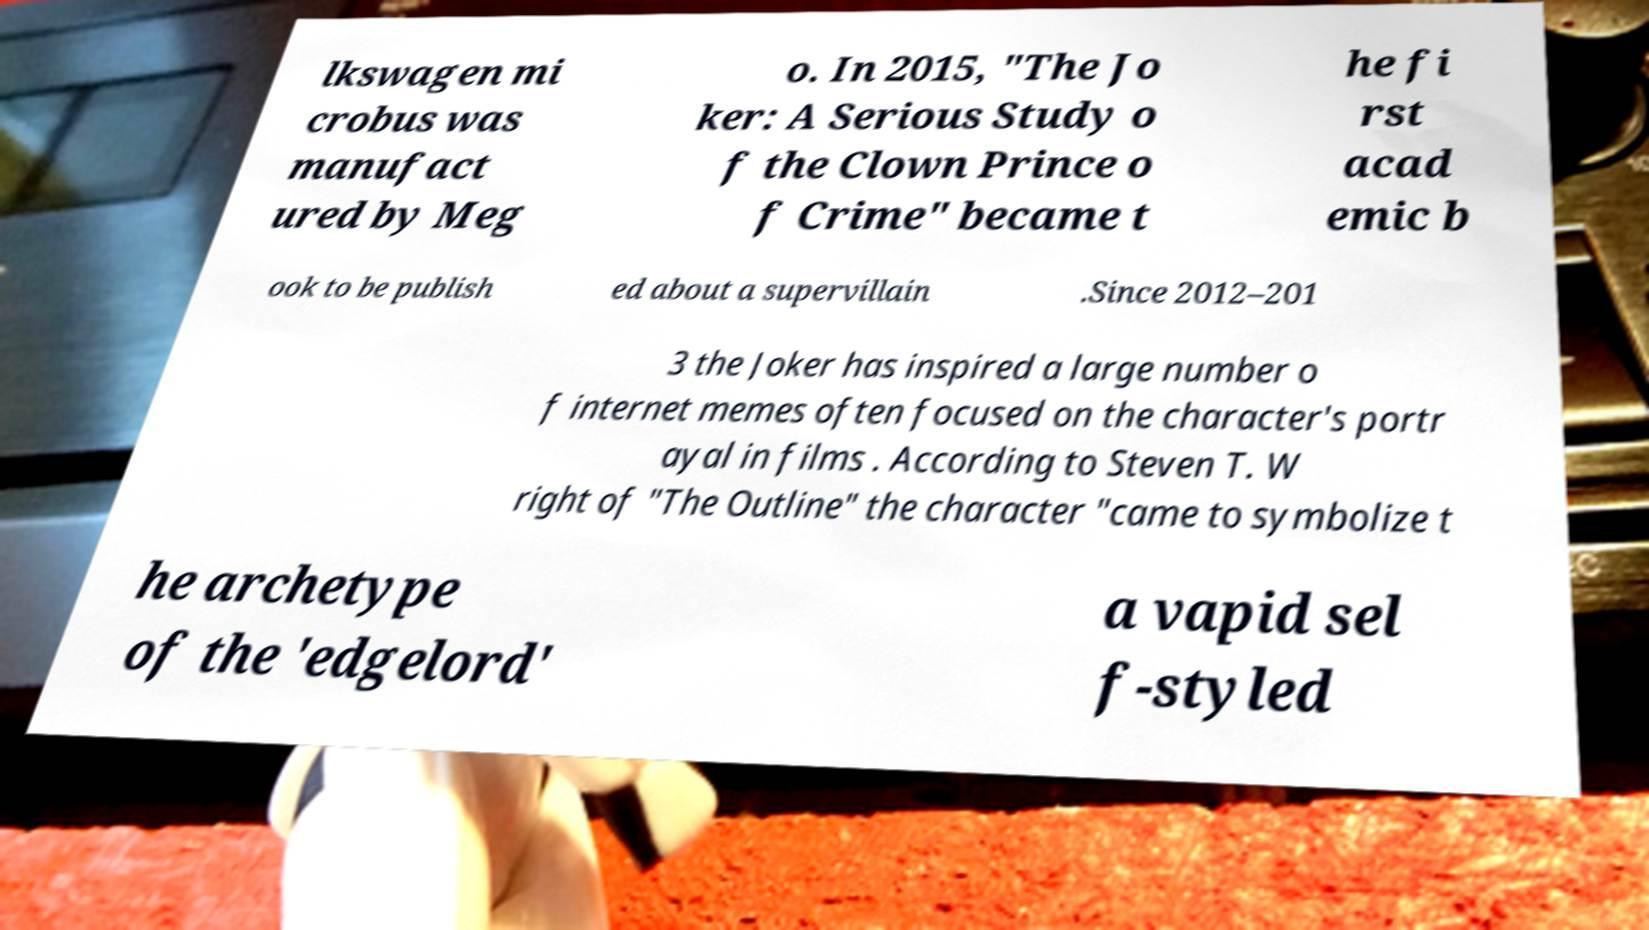What messages or text are displayed in this image? I need them in a readable, typed format. lkswagen mi crobus was manufact ured by Meg o. In 2015, "The Jo ker: A Serious Study o f the Clown Prince o f Crime" became t he fi rst acad emic b ook to be publish ed about a supervillain .Since 2012–201 3 the Joker has inspired a large number o f internet memes often focused on the character's portr ayal in films . According to Steven T. W right of "The Outline" the character "came to symbolize t he archetype of the 'edgelord' a vapid sel f-styled 